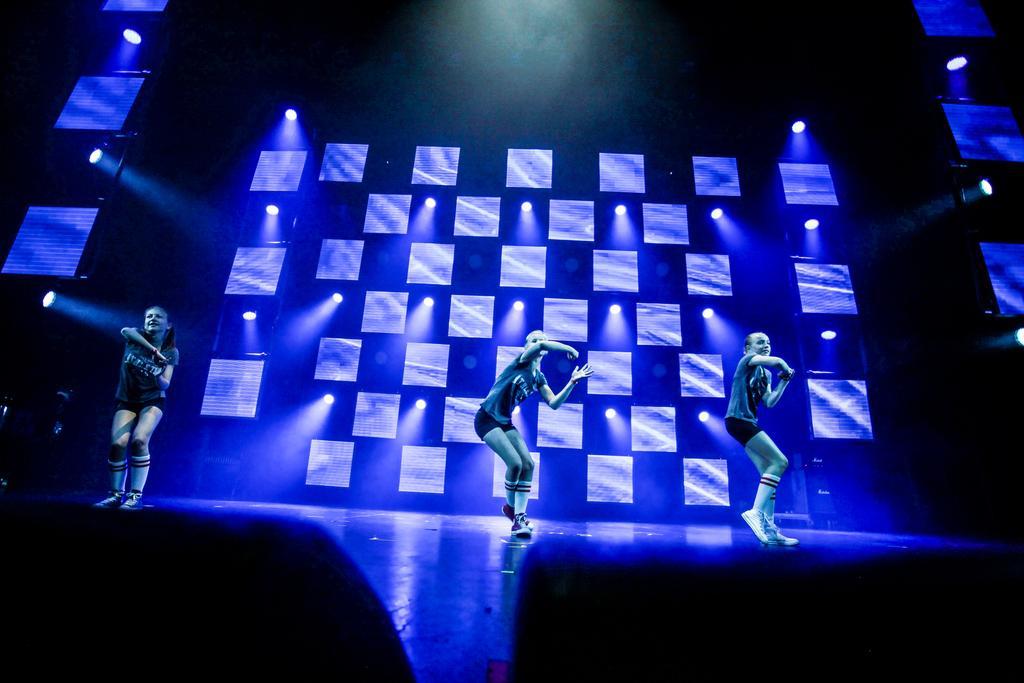In one or two sentences, can you explain what this image depicts? In the picture we can see three people are dancing on the stage. Behind them, we can see a wall with blue color lights. 